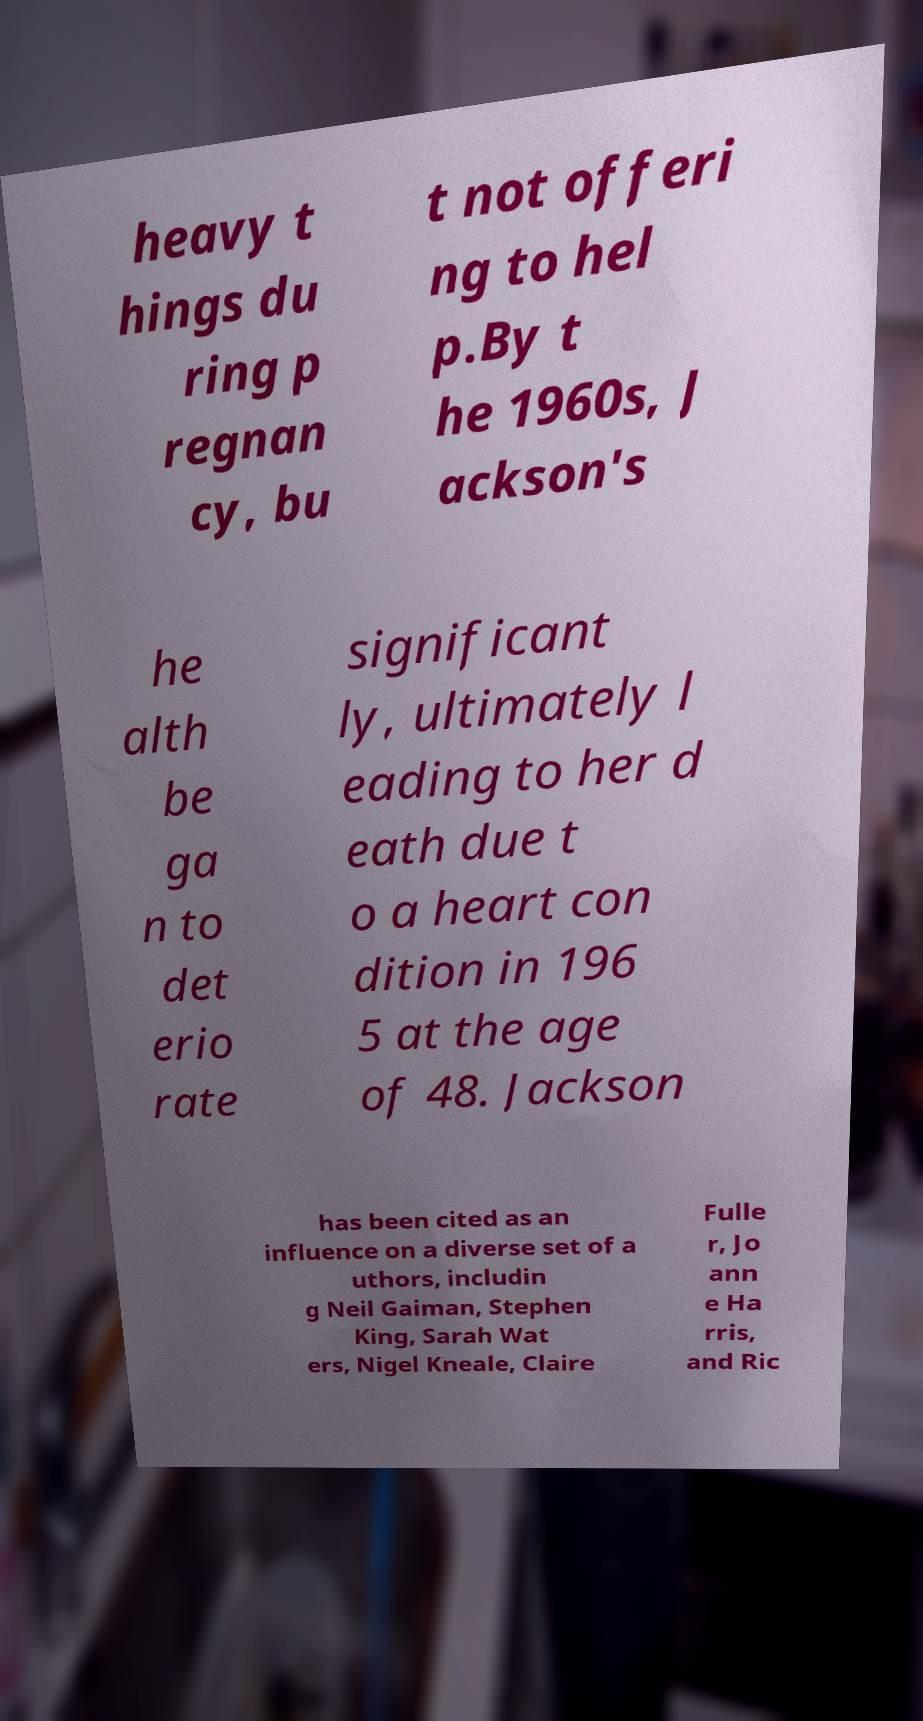What messages or text are displayed in this image? I need them in a readable, typed format. heavy t hings du ring p regnan cy, bu t not offeri ng to hel p.By t he 1960s, J ackson's he alth be ga n to det erio rate significant ly, ultimately l eading to her d eath due t o a heart con dition in 196 5 at the age of 48. Jackson has been cited as an influence on a diverse set of a uthors, includin g Neil Gaiman, Stephen King, Sarah Wat ers, Nigel Kneale, Claire Fulle r, Jo ann e Ha rris, and Ric 